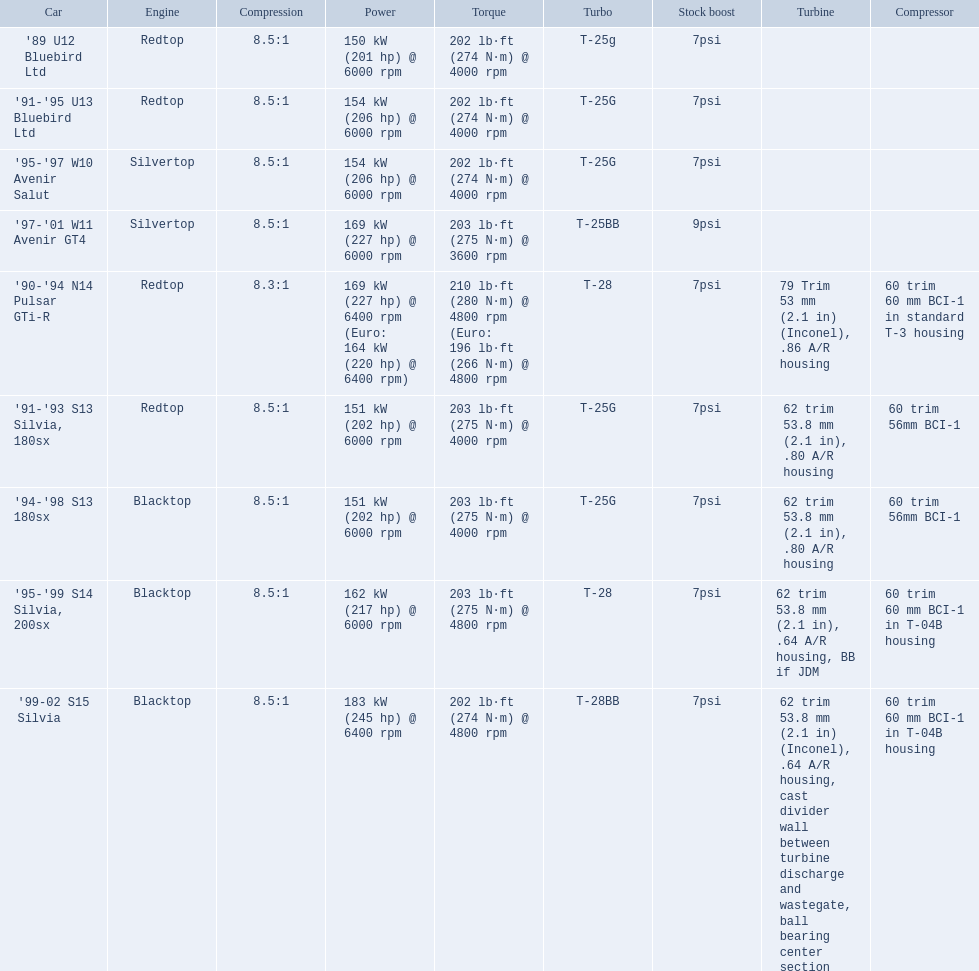What are the psi units? 7psi, 7psi, 7psi, 9psi, 7psi, 7psi, 7psi, 7psi, 7psi. What are the numeral(s) surpassing 7? 9psi. Which auto contains that numeral? '97-'01 W11 Avenir GT4. What are the various car models? '89 U12 Bluebird Ltd, '91-'95 U13 Bluebird Ltd, '95-'97 W10 Avenir Salut, '97-'01 W11 Avenir GT4, '90-'94 N14 Pulsar GTi-R, '91-'93 S13 Silvia, 180sx, '94-'98 S13 180sx, '95-'99 S14 Silvia, 200sx, '99-02 S15 Silvia. What is their respective power rating? 150 kW (201 hp) @ 6000 rpm, 154 kW (206 hp) @ 6000 rpm, 154 kW (206 hp) @ 6000 rpm, 169 kW (227 hp) @ 6000 rpm, 169 kW (227 hp) @ 6400 rpm (Euro: 164 kW (220 hp) @ 6400 rpm), 151 kW (202 hp) @ 6000 rpm, 151 kW (202 hp) @ 6000 rpm, 162 kW (217 hp) @ 6000 rpm, 183 kW (245 hp) @ 6400 rpm. Which vehicle has the highest power? '99-02 S15 Silvia. What is the composition of the psi's? 7psi, 7psi, 7psi, 9psi, 7psi, 7psi, 7psi, 7psi, 7psi. Which numeral(s) exceed 7? 9psi. Which vehicle holds that specific number? '97-'01 W11 Avenir GT4. 